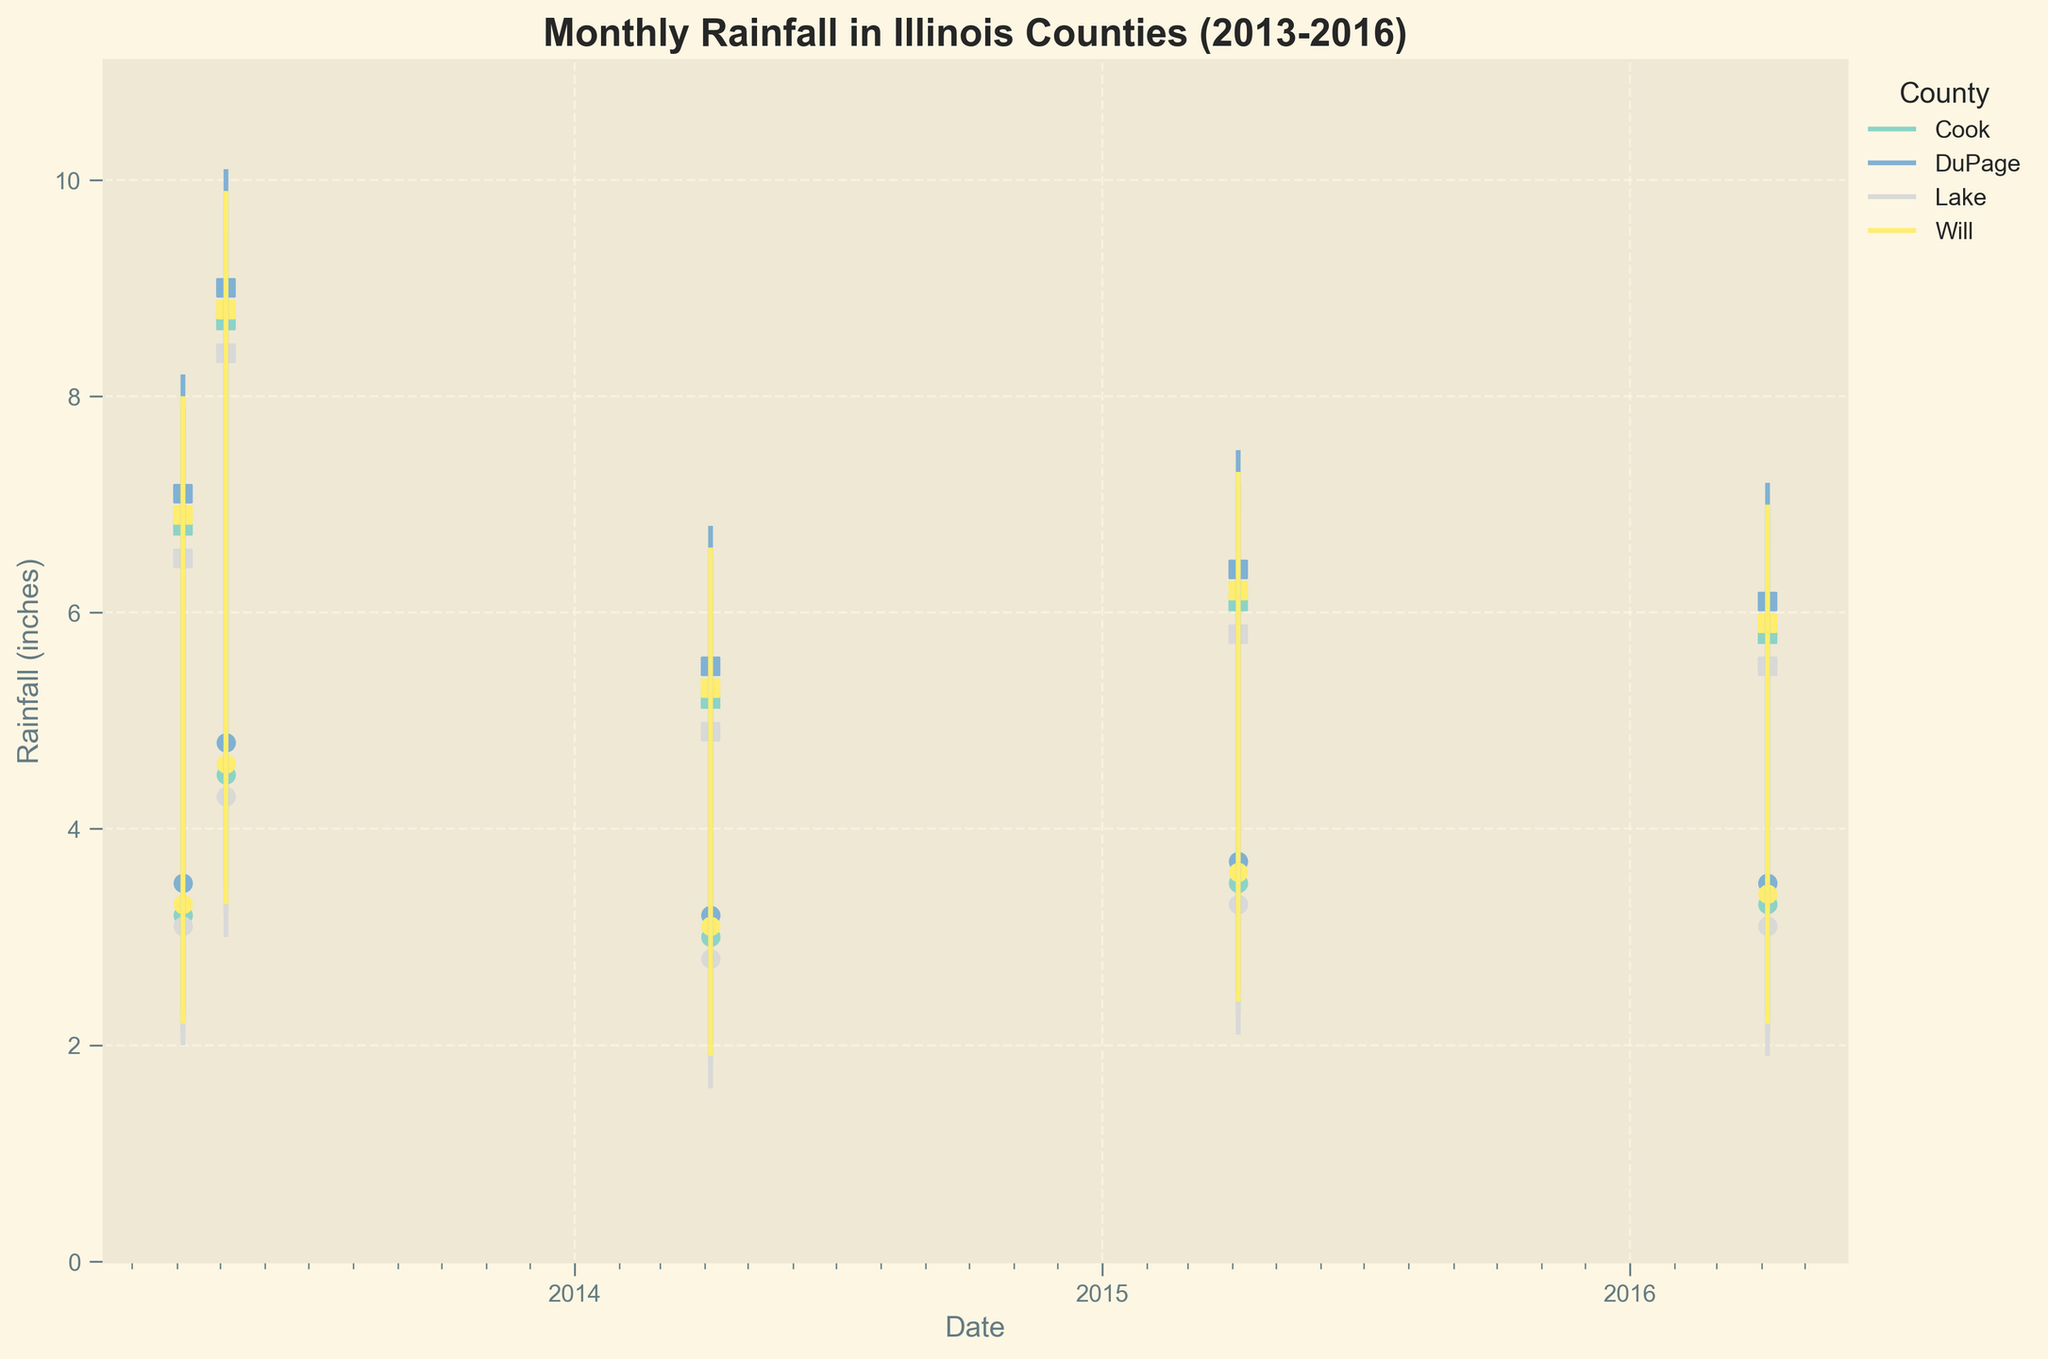Which county had the highest rainfall in May 2013? By examining the high points for May 2013, you can see that DuPage had the highest value at 10.1 inches.
Answer: DuPage What were the opening and closing rainfall values for Cook County in April 2014? Looking at the specific data points for Cook County in April 2014, the opening rainfall was 3.0 inches and the closing rainfall was 5.2 inches.
Answer: Opening: 3.0 inches, Closing: 5.2 inches Which month had the lowest closing rainfall for Lake County from 2013 to 2016? By comparing the closing values for Lake County across all months, the lowest closing rainfall occurred in April 2014 at 4.9 inches.
Answer: April 2014 How did the rainfall in Will County change from April 2013 to May 2013? To determine the change in rainfall, subtract the closing value of April 2013 (6.9 inches) from the closing value of May 2013 (8.8 inches). The change is 8.8 - 6.9 = 1.9 inches.
Answer: Increased by 1.9 inches Compare the average low rainfall for Cook County and Lake County in April from 2013 to 2016. Calculate the average low rainfall for Cook County in April: (2.1 + 1.8 + 2.3 + 2.1) / 4 = 2.075 inches. Calculate the average low rainfall for Lake County in April: (2.0 + 1.6 + 2.1 + 1.9) / 4 = 1.9 inches.
Answer: Cook: 2.075 inches, Lake: 1.9 inches Which county had the highest increase in closing rainfall from April 2013 to May 2013? Compare the increase for each county by subtracting the April closing values from May closing values: Cook (8.7 - 6.8 = 1.9), DuPage (9.0 - 7.1 = 1.9), Lake (8.4 - 6.5 = 1.9), Will (8.8 - 6.9 = 1.9). All counties had the same increase of 1.9 inches.
Answer: All counties had the same increase What is the range of rainfall in DuPage County for April 2014? The range is calculated by subtracting the low value from the high value: 6.8 - 2.0 = 4.8 inches.
Answer: 4.8 inches Which county had the smallest range in rainfall for April 2016? Calculate the range for each county: Cook (6.9 - 2.1 = 4.8), DuPage (7.2 - 2.3 = 4.9), Lake (6.6 - 1.9 = 4.7), Will (7.0 - 2.2 = 4.8). The smallest range is in Lake County at 4.7 inches.
Answer: Lake County What is the average closing rainfall for all counties in May 2013? Add up the closing values for all counties and divide by the number of counties: (8.7 + 9.0 + 8.4 + 8.8) / 4 = 8.725 inches.
Answer: 8.725 inches 